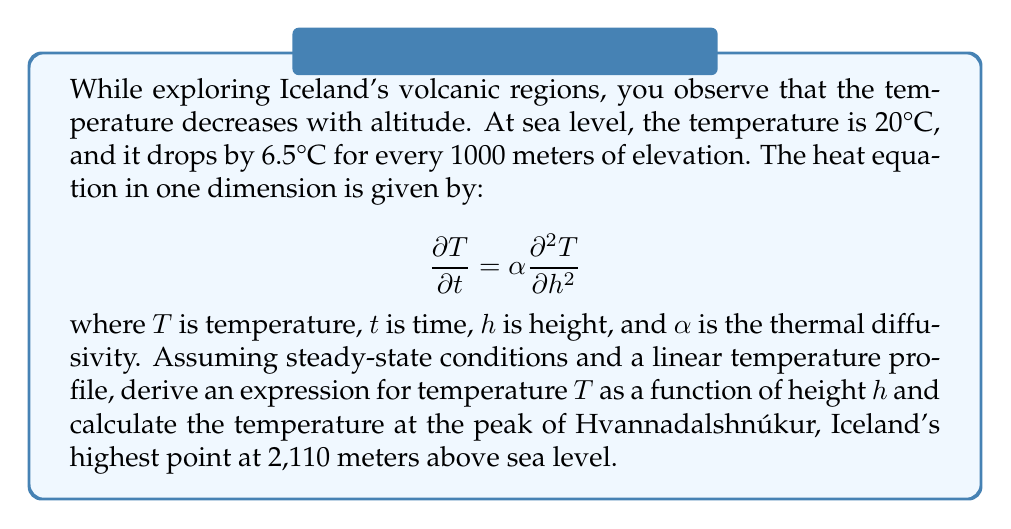Provide a solution to this math problem. To solve this problem, we'll follow these steps:

1) In steady-state conditions, the temperature doesn't change with time, so $\frac{\partial T}{\partial t} = 0$. This simplifies our heat equation to:

   $$0 = \alpha \frac{\partial^2 T}{\partial h^2}$$

2) This implies that $\frac{\partial^2 T}{\partial h^2} = 0$, meaning the temperature profile is linear with respect to height.

3) We can express this linear relationship as:

   $$T(h) = T_0 + mh$$

   where $T_0$ is the temperature at sea level (20°C) and $m$ is the rate of temperature change with height.

4) We're given that the temperature drops by 6.5°C per 1000 meters, so:

   $$m = -\frac{6.5°C}{1000m} = -0.0065 °C/m$$

5) Now we can write our full equation for temperature as a function of height:

   $$T(h) = 20 - 0.0065h$$

   where $h$ is in meters and $T$ is in °C.

6) To find the temperature at the peak of Hvannadalshnúkur (2,110 meters), we substitute this height into our equation:

   $$T(2110) = 20 - 0.0065 \cdot 2110 = 20 - 13.715 = 6.285°C$$

Therefore, the temperature at the peak is approximately 6.3°C.
Answer: $T(h) = 20 - 0.0065h$; 6.3°C at 2,110 meters 